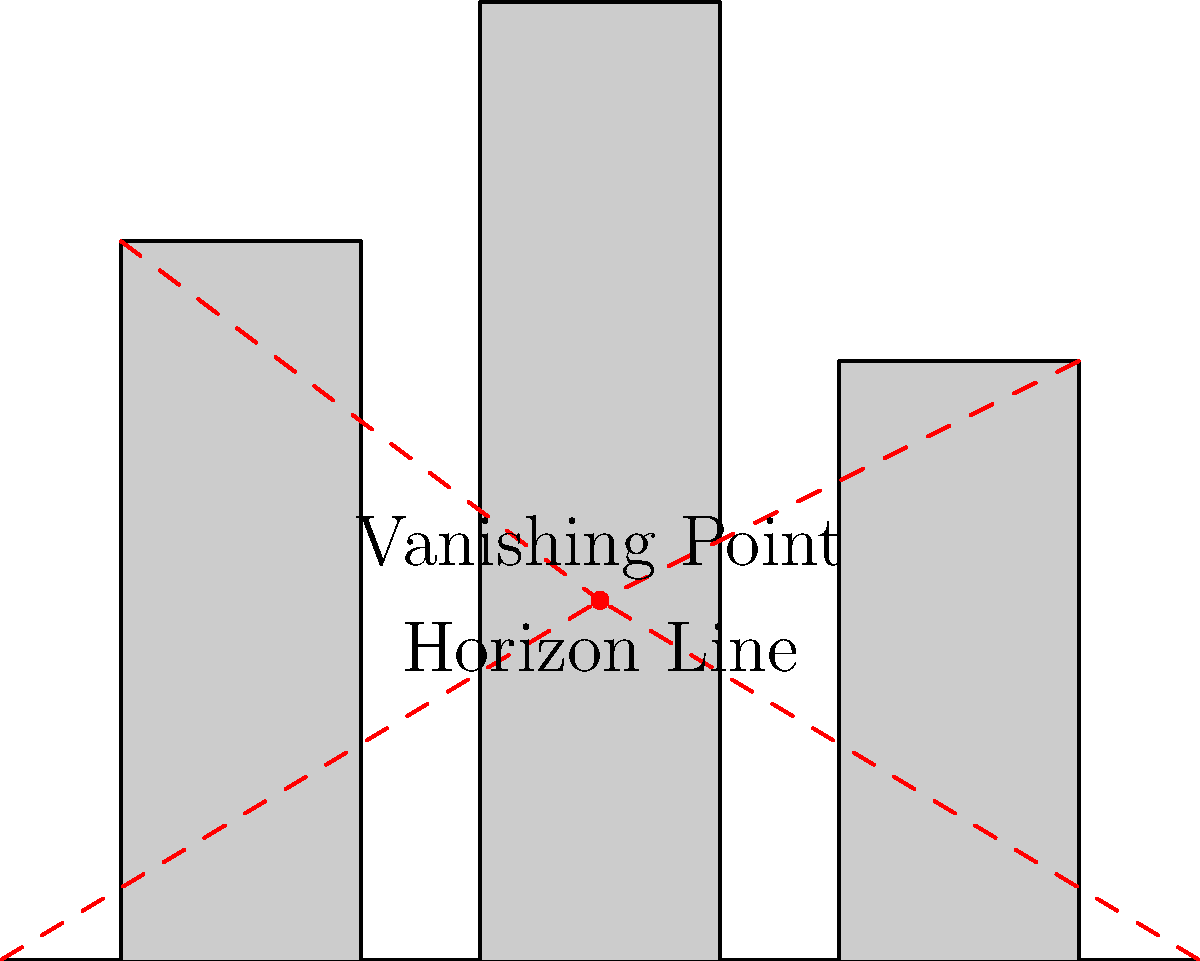In the cityscape diagram above, which element is crucial for creating a sense of depth and perspective in a graphic novel scene, and how does it contribute to the overall composition? 1. The key element in this cityscape for creating depth and perspective is the vanishing point.

2. The vanishing point is located on the horizon line, which is positioned about one-third of the way up the image.

3. Perspective lines (shown in red) converge at this vanishing point, creating the illusion of depth.

4. The buildings in the scene are drawn to align with these perspective lines:
   a. The tops of the buildings appear to slope towards the vanishing point.
   b. The sides of the buildings also follow the perspective lines.

5. This use of linear perspective creates a realistic sense of depth and distance in the 2D image.

6. In a graphic novel scene, this technique would make the cityscape appear more three-dimensional and immersive.

7. The placement of the vanishing point also influences the viewer's perspective:
   a. A lower vanishing point would create a "worm's eye view."
   b. A higher vanishing point would result in a "bird's eye view."

8. The current mid-level placement creates a balanced, eye-level view of the city.

9. Artists can manipulate this technique to create different moods or emphasize certain elements in their graphic novel scenes.
Answer: Vanishing point 